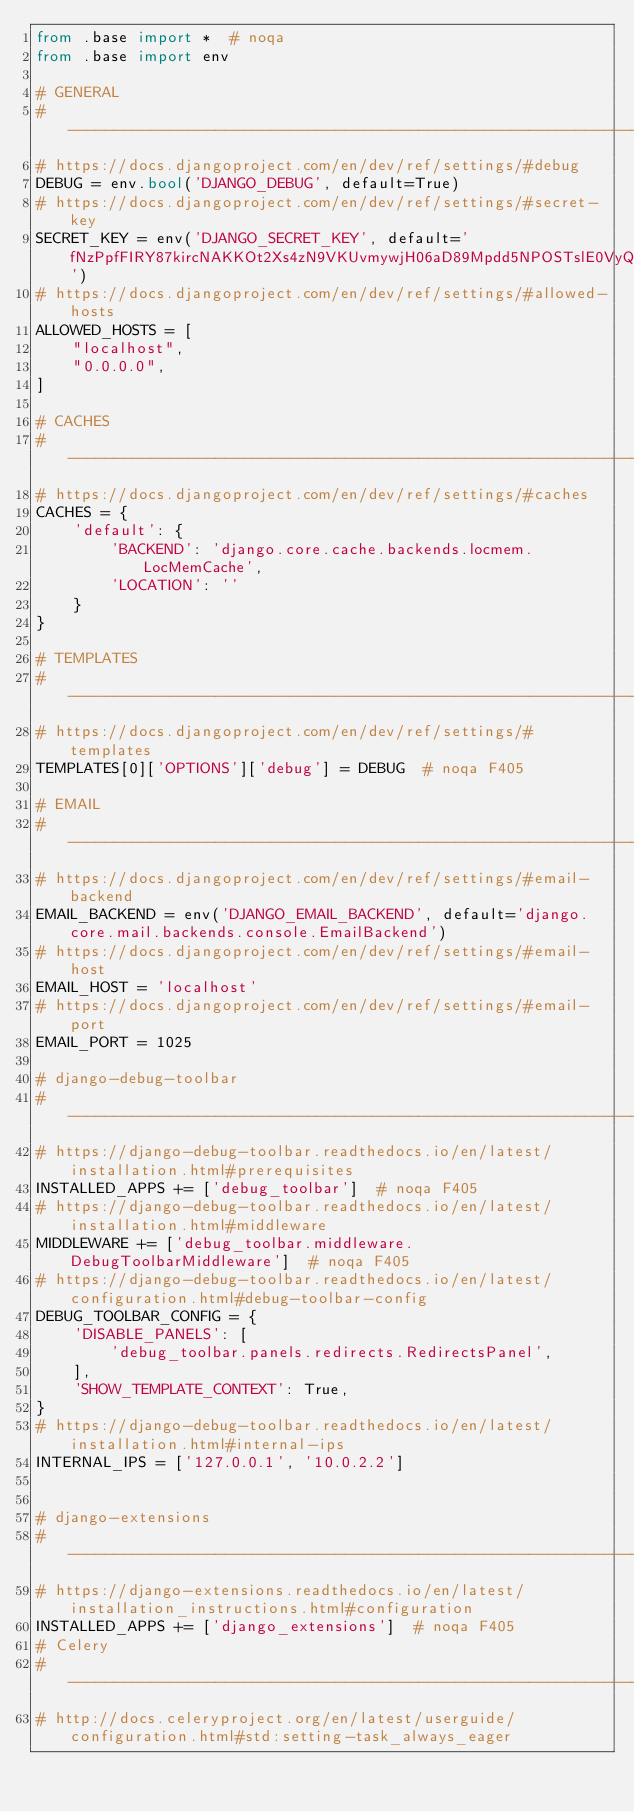<code> <loc_0><loc_0><loc_500><loc_500><_Python_>from .base import *  # noqa
from .base import env

# GENERAL
# ------------------------------------------------------------------------------
# https://docs.djangoproject.com/en/dev/ref/settings/#debug
DEBUG = env.bool('DJANGO_DEBUG', default=True)
# https://docs.djangoproject.com/en/dev/ref/settings/#secret-key
SECRET_KEY = env('DJANGO_SECRET_KEY', default='fNzPpfFIRY87kircNAKKOt2Xs4zN9VKUvmywjH06aD89Mpdd5NPOSTslE0VyQ0lA')
# https://docs.djangoproject.com/en/dev/ref/settings/#allowed-hosts
ALLOWED_HOSTS = [
    "localhost",
    "0.0.0.0",
]

# CACHES
# ------------------------------------------------------------------------------
# https://docs.djangoproject.com/en/dev/ref/settings/#caches
CACHES = {
    'default': {
        'BACKEND': 'django.core.cache.backends.locmem.LocMemCache',
        'LOCATION': ''
    }
}

# TEMPLATES
# ------------------------------------------------------------------------------
# https://docs.djangoproject.com/en/dev/ref/settings/#templates
TEMPLATES[0]['OPTIONS']['debug'] = DEBUG  # noqa F405

# EMAIL
# ------------------------------------------------------------------------------
# https://docs.djangoproject.com/en/dev/ref/settings/#email-backend
EMAIL_BACKEND = env('DJANGO_EMAIL_BACKEND', default='django.core.mail.backends.console.EmailBackend')
# https://docs.djangoproject.com/en/dev/ref/settings/#email-host
EMAIL_HOST = 'localhost'
# https://docs.djangoproject.com/en/dev/ref/settings/#email-port
EMAIL_PORT = 1025

# django-debug-toolbar
# ------------------------------------------------------------------------------
# https://django-debug-toolbar.readthedocs.io/en/latest/installation.html#prerequisites
INSTALLED_APPS += ['debug_toolbar']  # noqa F405
# https://django-debug-toolbar.readthedocs.io/en/latest/installation.html#middleware
MIDDLEWARE += ['debug_toolbar.middleware.DebugToolbarMiddleware']  # noqa F405
# https://django-debug-toolbar.readthedocs.io/en/latest/configuration.html#debug-toolbar-config
DEBUG_TOOLBAR_CONFIG = {
    'DISABLE_PANELS': [
        'debug_toolbar.panels.redirects.RedirectsPanel',
    ],
    'SHOW_TEMPLATE_CONTEXT': True,
}
# https://django-debug-toolbar.readthedocs.io/en/latest/installation.html#internal-ips
INTERNAL_IPS = ['127.0.0.1', '10.0.2.2']


# django-extensions
# ------------------------------------------------------------------------------
# https://django-extensions.readthedocs.io/en/latest/installation_instructions.html#configuration
INSTALLED_APPS += ['django_extensions']  # noqa F405
# Celery
# ------------------------------------------------------------------------------
# http://docs.celeryproject.org/en/latest/userguide/configuration.html#std:setting-task_always_eager</code> 